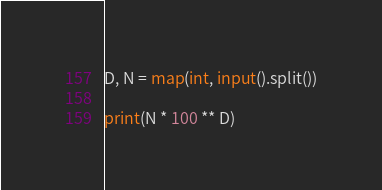Convert code to text. <code><loc_0><loc_0><loc_500><loc_500><_Python_>D, N = map(int, input().split())

print(N * 100 ** D)</code> 